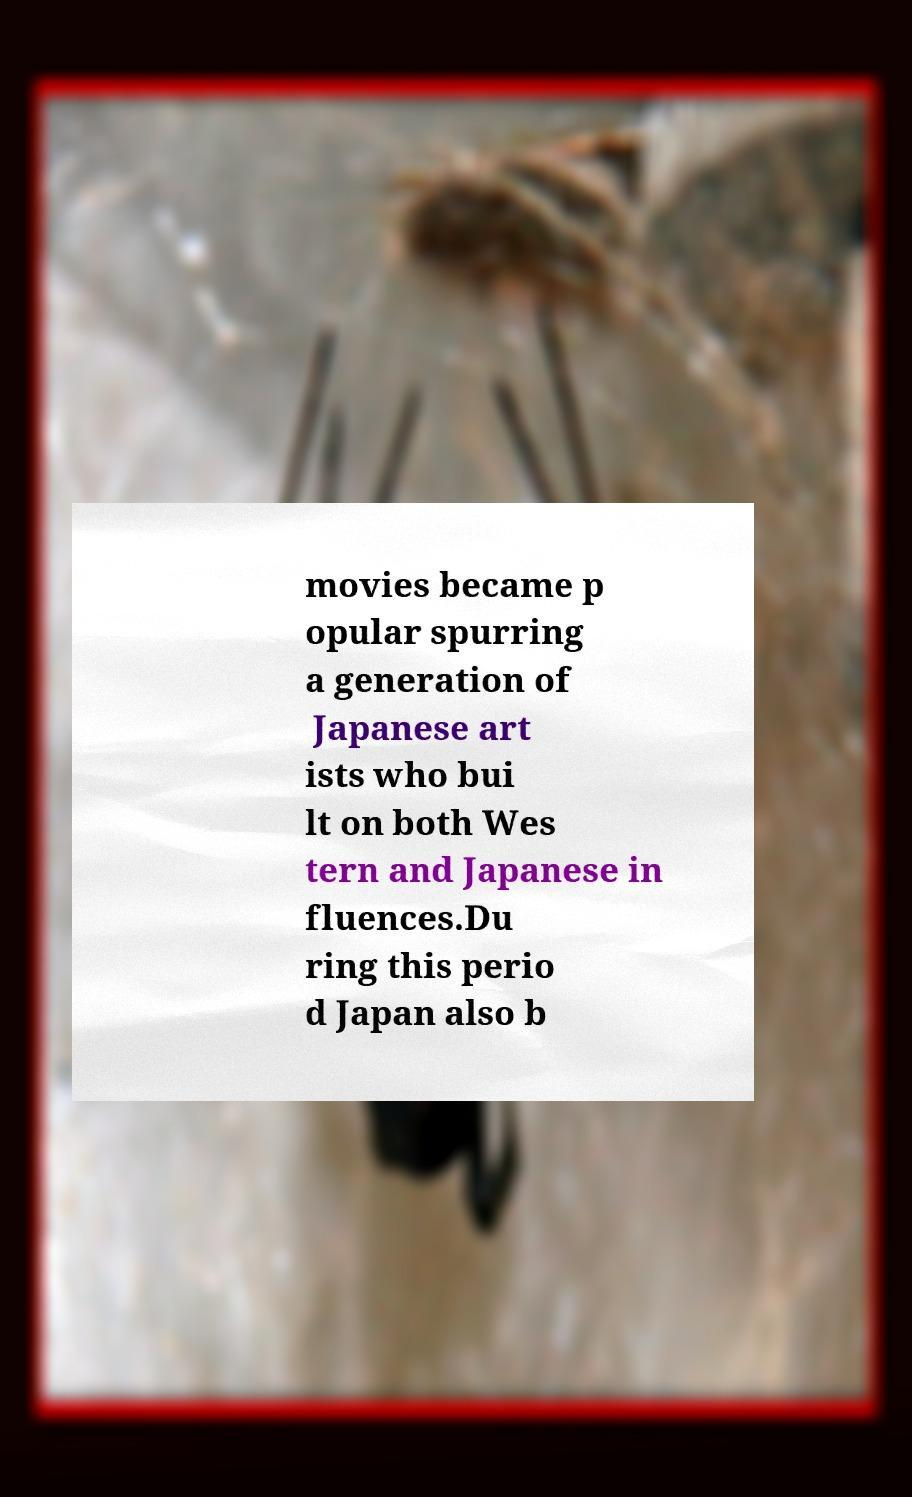For documentation purposes, I need the text within this image transcribed. Could you provide that? movies became p opular spurring a generation of Japanese art ists who bui lt on both Wes tern and Japanese in fluences.Du ring this perio d Japan also b 